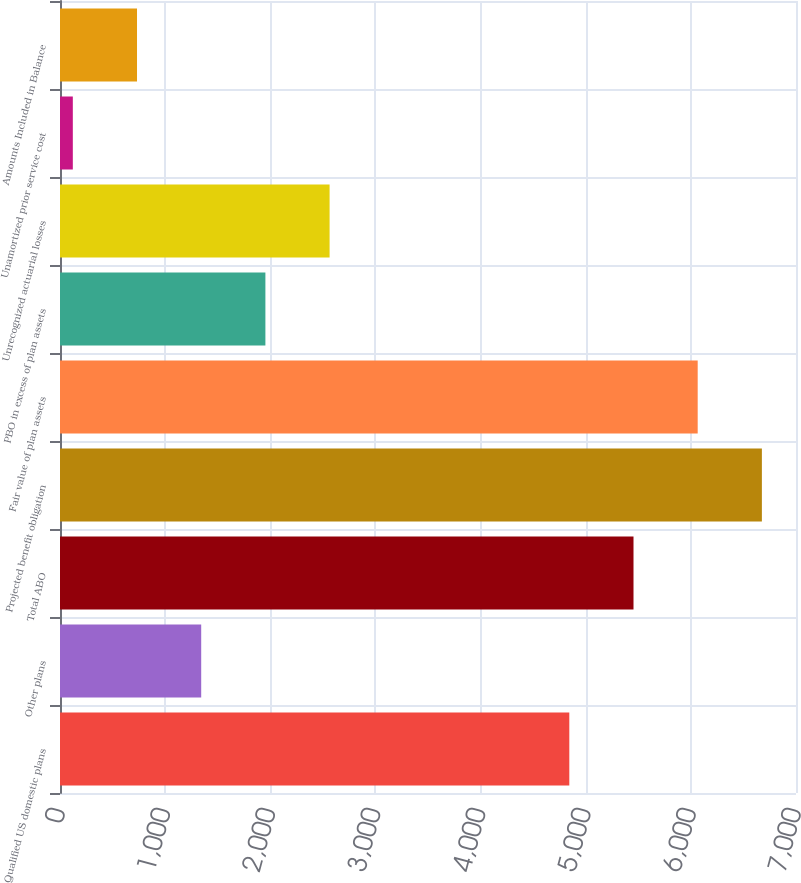<chart> <loc_0><loc_0><loc_500><loc_500><bar_chart><fcel>Qualified US domestic plans<fcel>Other plans<fcel>Total ABO<fcel>Projected benefit obligation<fcel>Fair value of plan assets<fcel>PBO in excess of plan assets<fcel>Unrecognized actuarial losses<fcel>Unamortized prior service cost<fcel>Amounts Included in Balance<nl><fcel>4844<fcel>1343<fcel>5454.5<fcel>6675.5<fcel>6065<fcel>1953.5<fcel>2564<fcel>122<fcel>732.5<nl></chart> 